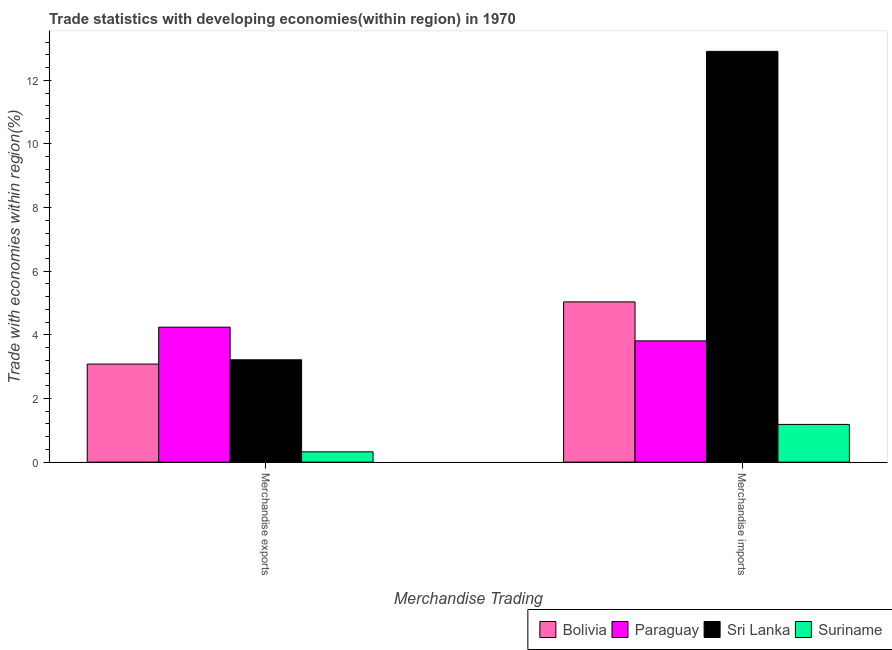How many different coloured bars are there?
Provide a short and direct response. 4. Are the number of bars per tick equal to the number of legend labels?
Make the answer very short. Yes. Are the number of bars on each tick of the X-axis equal?
Ensure brevity in your answer.  Yes. How many bars are there on the 1st tick from the left?
Your response must be concise. 4. How many bars are there on the 2nd tick from the right?
Your answer should be compact. 4. What is the label of the 1st group of bars from the left?
Make the answer very short. Merchandise exports. What is the merchandise exports in Bolivia?
Provide a succinct answer. 3.08. Across all countries, what is the maximum merchandise imports?
Provide a succinct answer. 12.91. Across all countries, what is the minimum merchandise imports?
Provide a short and direct response. 1.19. In which country was the merchandise imports maximum?
Provide a short and direct response. Sri Lanka. In which country was the merchandise exports minimum?
Ensure brevity in your answer.  Suriname. What is the total merchandise imports in the graph?
Offer a very short reply. 22.94. What is the difference between the merchandise exports in Sri Lanka and that in Paraguay?
Provide a succinct answer. -1.03. What is the difference between the merchandise imports in Sri Lanka and the merchandise exports in Bolivia?
Provide a succinct answer. 9.83. What is the average merchandise exports per country?
Your response must be concise. 2.72. What is the difference between the merchandise exports and merchandise imports in Suriname?
Keep it short and to the point. -0.86. In how many countries, is the merchandise exports greater than 6.8 %?
Your answer should be compact. 0. What is the ratio of the merchandise exports in Sri Lanka to that in Bolivia?
Your response must be concise. 1.04. Is the merchandise imports in Sri Lanka less than that in Paraguay?
Offer a very short reply. No. In how many countries, is the merchandise imports greater than the average merchandise imports taken over all countries?
Your response must be concise. 1. What does the 3rd bar from the left in Merchandise imports represents?
Make the answer very short. Sri Lanka. What does the 2nd bar from the right in Merchandise exports represents?
Ensure brevity in your answer.  Sri Lanka. How many bars are there?
Give a very brief answer. 8. Are all the bars in the graph horizontal?
Give a very brief answer. No. How many countries are there in the graph?
Your response must be concise. 4. What is the difference between two consecutive major ticks on the Y-axis?
Provide a short and direct response. 2. Are the values on the major ticks of Y-axis written in scientific E-notation?
Your answer should be compact. No. Where does the legend appear in the graph?
Make the answer very short. Bottom right. How many legend labels are there?
Make the answer very short. 4. How are the legend labels stacked?
Your response must be concise. Horizontal. What is the title of the graph?
Make the answer very short. Trade statistics with developing economies(within region) in 1970. What is the label or title of the X-axis?
Make the answer very short. Merchandise Trading. What is the label or title of the Y-axis?
Offer a terse response. Trade with economies within region(%). What is the Trade with economies within region(%) of Bolivia in Merchandise exports?
Offer a very short reply. 3.08. What is the Trade with economies within region(%) of Paraguay in Merchandise exports?
Offer a very short reply. 4.24. What is the Trade with economies within region(%) of Sri Lanka in Merchandise exports?
Keep it short and to the point. 3.22. What is the Trade with economies within region(%) of Suriname in Merchandise exports?
Give a very brief answer. 0.32. What is the Trade with economies within region(%) of Bolivia in Merchandise imports?
Offer a very short reply. 5.04. What is the Trade with economies within region(%) of Paraguay in Merchandise imports?
Keep it short and to the point. 3.81. What is the Trade with economies within region(%) of Sri Lanka in Merchandise imports?
Make the answer very short. 12.91. What is the Trade with economies within region(%) in Suriname in Merchandise imports?
Make the answer very short. 1.19. Across all Merchandise Trading, what is the maximum Trade with economies within region(%) in Bolivia?
Your answer should be very brief. 5.04. Across all Merchandise Trading, what is the maximum Trade with economies within region(%) of Paraguay?
Give a very brief answer. 4.24. Across all Merchandise Trading, what is the maximum Trade with economies within region(%) of Sri Lanka?
Your answer should be very brief. 12.91. Across all Merchandise Trading, what is the maximum Trade with economies within region(%) in Suriname?
Ensure brevity in your answer.  1.19. Across all Merchandise Trading, what is the minimum Trade with economies within region(%) in Bolivia?
Offer a terse response. 3.08. Across all Merchandise Trading, what is the minimum Trade with economies within region(%) of Paraguay?
Keep it short and to the point. 3.81. Across all Merchandise Trading, what is the minimum Trade with economies within region(%) of Sri Lanka?
Your answer should be compact. 3.22. Across all Merchandise Trading, what is the minimum Trade with economies within region(%) of Suriname?
Give a very brief answer. 0.32. What is the total Trade with economies within region(%) of Bolivia in the graph?
Your answer should be compact. 8.12. What is the total Trade with economies within region(%) in Paraguay in the graph?
Offer a terse response. 8.05. What is the total Trade with economies within region(%) in Sri Lanka in the graph?
Keep it short and to the point. 16.13. What is the total Trade with economies within region(%) of Suriname in the graph?
Your response must be concise. 1.51. What is the difference between the Trade with economies within region(%) in Bolivia in Merchandise exports and that in Merchandise imports?
Offer a very short reply. -1.95. What is the difference between the Trade with economies within region(%) of Paraguay in Merchandise exports and that in Merchandise imports?
Give a very brief answer. 0.43. What is the difference between the Trade with economies within region(%) in Sri Lanka in Merchandise exports and that in Merchandise imports?
Provide a succinct answer. -9.69. What is the difference between the Trade with economies within region(%) in Suriname in Merchandise exports and that in Merchandise imports?
Offer a very short reply. -0.86. What is the difference between the Trade with economies within region(%) in Bolivia in Merchandise exports and the Trade with economies within region(%) in Paraguay in Merchandise imports?
Offer a terse response. -0.73. What is the difference between the Trade with economies within region(%) of Bolivia in Merchandise exports and the Trade with economies within region(%) of Sri Lanka in Merchandise imports?
Your response must be concise. -9.83. What is the difference between the Trade with economies within region(%) in Bolivia in Merchandise exports and the Trade with economies within region(%) in Suriname in Merchandise imports?
Keep it short and to the point. 1.9. What is the difference between the Trade with economies within region(%) of Paraguay in Merchandise exports and the Trade with economies within region(%) of Sri Lanka in Merchandise imports?
Provide a short and direct response. -8.67. What is the difference between the Trade with economies within region(%) of Paraguay in Merchandise exports and the Trade with economies within region(%) of Suriname in Merchandise imports?
Provide a succinct answer. 3.06. What is the difference between the Trade with economies within region(%) in Sri Lanka in Merchandise exports and the Trade with economies within region(%) in Suriname in Merchandise imports?
Ensure brevity in your answer.  2.03. What is the average Trade with economies within region(%) in Bolivia per Merchandise Trading?
Make the answer very short. 4.06. What is the average Trade with economies within region(%) in Paraguay per Merchandise Trading?
Your answer should be compact. 4.03. What is the average Trade with economies within region(%) in Sri Lanka per Merchandise Trading?
Offer a terse response. 8.06. What is the average Trade with economies within region(%) in Suriname per Merchandise Trading?
Your answer should be compact. 0.75. What is the difference between the Trade with economies within region(%) in Bolivia and Trade with economies within region(%) in Paraguay in Merchandise exports?
Offer a very short reply. -1.16. What is the difference between the Trade with economies within region(%) in Bolivia and Trade with economies within region(%) in Sri Lanka in Merchandise exports?
Provide a short and direct response. -0.13. What is the difference between the Trade with economies within region(%) of Bolivia and Trade with economies within region(%) of Suriname in Merchandise exports?
Keep it short and to the point. 2.76. What is the difference between the Trade with economies within region(%) of Paraguay and Trade with economies within region(%) of Sri Lanka in Merchandise exports?
Your answer should be very brief. 1.03. What is the difference between the Trade with economies within region(%) of Paraguay and Trade with economies within region(%) of Suriname in Merchandise exports?
Offer a terse response. 3.92. What is the difference between the Trade with economies within region(%) in Sri Lanka and Trade with economies within region(%) in Suriname in Merchandise exports?
Your answer should be compact. 2.89. What is the difference between the Trade with economies within region(%) of Bolivia and Trade with economies within region(%) of Paraguay in Merchandise imports?
Give a very brief answer. 1.23. What is the difference between the Trade with economies within region(%) of Bolivia and Trade with economies within region(%) of Sri Lanka in Merchandise imports?
Offer a terse response. -7.88. What is the difference between the Trade with economies within region(%) of Bolivia and Trade with economies within region(%) of Suriname in Merchandise imports?
Your response must be concise. 3.85. What is the difference between the Trade with economies within region(%) in Paraguay and Trade with economies within region(%) in Sri Lanka in Merchandise imports?
Offer a very short reply. -9.1. What is the difference between the Trade with economies within region(%) of Paraguay and Trade with economies within region(%) of Suriname in Merchandise imports?
Provide a succinct answer. 2.63. What is the difference between the Trade with economies within region(%) in Sri Lanka and Trade with economies within region(%) in Suriname in Merchandise imports?
Offer a terse response. 11.73. What is the ratio of the Trade with economies within region(%) in Bolivia in Merchandise exports to that in Merchandise imports?
Provide a succinct answer. 0.61. What is the ratio of the Trade with economies within region(%) of Paraguay in Merchandise exports to that in Merchandise imports?
Your response must be concise. 1.11. What is the ratio of the Trade with economies within region(%) of Sri Lanka in Merchandise exports to that in Merchandise imports?
Keep it short and to the point. 0.25. What is the ratio of the Trade with economies within region(%) of Suriname in Merchandise exports to that in Merchandise imports?
Offer a very short reply. 0.27. What is the difference between the highest and the second highest Trade with economies within region(%) of Bolivia?
Give a very brief answer. 1.95. What is the difference between the highest and the second highest Trade with economies within region(%) of Paraguay?
Your answer should be compact. 0.43. What is the difference between the highest and the second highest Trade with economies within region(%) of Sri Lanka?
Provide a succinct answer. 9.69. What is the difference between the highest and the second highest Trade with economies within region(%) in Suriname?
Your response must be concise. 0.86. What is the difference between the highest and the lowest Trade with economies within region(%) of Bolivia?
Provide a succinct answer. 1.95. What is the difference between the highest and the lowest Trade with economies within region(%) in Paraguay?
Keep it short and to the point. 0.43. What is the difference between the highest and the lowest Trade with economies within region(%) in Sri Lanka?
Ensure brevity in your answer.  9.69. What is the difference between the highest and the lowest Trade with economies within region(%) in Suriname?
Give a very brief answer. 0.86. 